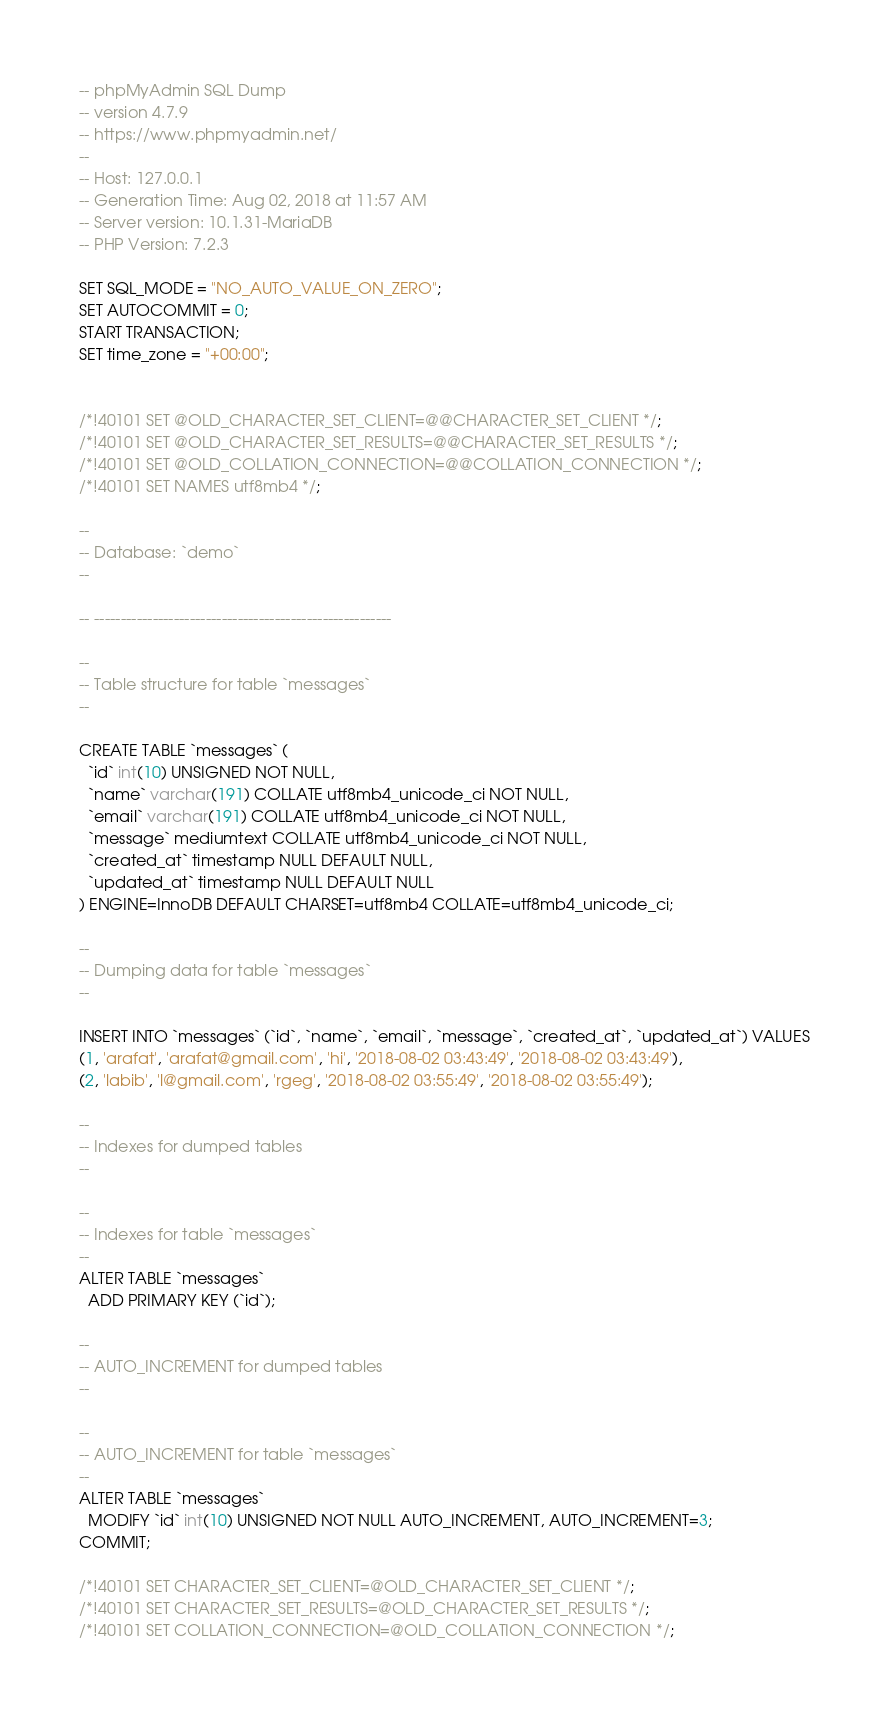Convert code to text. <code><loc_0><loc_0><loc_500><loc_500><_SQL_>-- phpMyAdmin SQL Dump
-- version 4.7.9
-- https://www.phpmyadmin.net/
--
-- Host: 127.0.0.1
-- Generation Time: Aug 02, 2018 at 11:57 AM
-- Server version: 10.1.31-MariaDB
-- PHP Version: 7.2.3

SET SQL_MODE = "NO_AUTO_VALUE_ON_ZERO";
SET AUTOCOMMIT = 0;
START TRANSACTION;
SET time_zone = "+00:00";


/*!40101 SET @OLD_CHARACTER_SET_CLIENT=@@CHARACTER_SET_CLIENT */;
/*!40101 SET @OLD_CHARACTER_SET_RESULTS=@@CHARACTER_SET_RESULTS */;
/*!40101 SET @OLD_COLLATION_CONNECTION=@@COLLATION_CONNECTION */;
/*!40101 SET NAMES utf8mb4 */;

--
-- Database: `demo`
--

-- --------------------------------------------------------

--
-- Table structure for table `messages`
--

CREATE TABLE `messages` (
  `id` int(10) UNSIGNED NOT NULL,
  `name` varchar(191) COLLATE utf8mb4_unicode_ci NOT NULL,
  `email` varchar(191) COLLATE utf8mb4_unicode_ci NOT NULL,
  `message` mediumtext COLLATE utf8mb4_unicode_ci NOT NULL,
  `created_at` timestamp NULL DEFAULT NULL,
  `updated_at` timestamp NULL DEFAULT NULL
) ENGINE=InnoDB DEFAULT CHARSET=utf8mb4 COLLATE=utf8mb4_unicode_ci;

--
-- Dumping data for table `messages`
--

INSERT INTO `messages` (`id`, `name`, `email`, `message`, `created_at`, `updated_at`) VALUES
(1, 'arafat', 'arafat@gmail.com', 'hi', '2018-08-02 03:43:49', '2018-08-02 03:43:49'),
(2, 'labib', 'l@gmail.com', 'rgeg', '2018-08-02 03:55:49', '2018-08-02 03:55:49');

--
-- Indexes for dumped tables
--

--
-- Indexes for table `messages`
--
ALTER TABLE `messages`
  ADD PRIMARY KEY (`id`);

--
-- AUTO_INCREMENT for dumped tables
--

--
-- AUTO_INCREMENT for table `messages`
--
ALTER TABLE `messages`
  MODIFY `id` int(10) UNSIGNED NOT NULL AUTO_INCREMENT, AUTO_INCREMENT=3;
COMMIT;

/*!40101 SET CHARACTER_SET_CLIENT=@OLD_CHARACTER_SET_CLIENT */;
/*!40101 SET CHARACTER_SET_RESULTS=@OLD_CHARACTER_SET_RESULTS */;
/*!40101 SET COLLATION_CONNECTION=@OLD_COLLATION_CONNECTION */;
</code> 